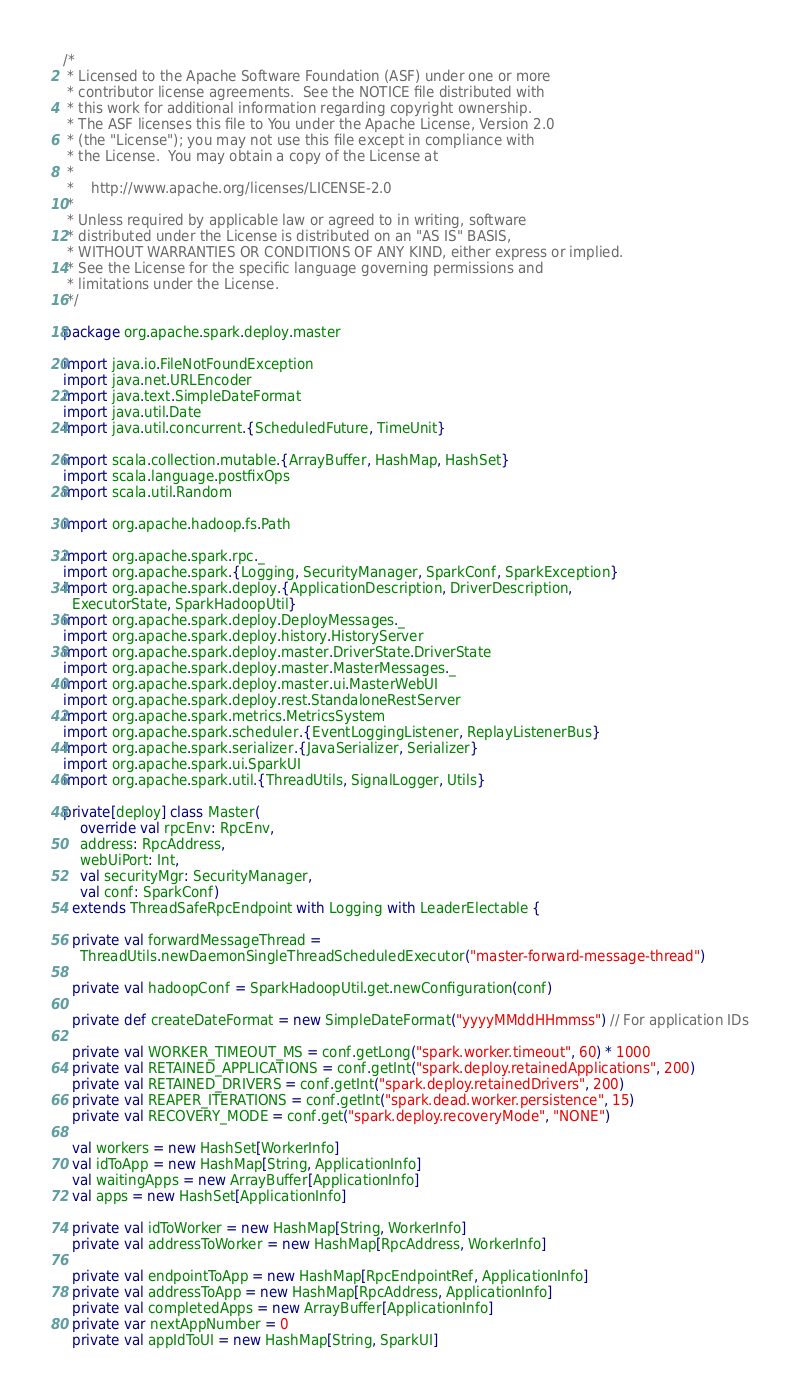Convert code to text. <code><loc_0><loc_0><loc_500><loc_500><_Scala_>/*
 * Licensed to the Apache Software Foundation (ASF) under one or more
 * contributor license agreements.  See the NOTICE file distributed with
 * this work for additional information regarding copyright ownership.
 * The ASF licenses this file to You under the Apache License, Version 2.0
 * (the "License"); you may not use this file except in compliance with
 * the License.  You may obtain a copy of the License at
 *
 *    http://www.apache.org/licenses/LICENSE-2.0
 *
 * Unless required by applicable law or agreed to in writing, software
 * distributed under the License is distributed on an "AS IS" BASIS,
 * WITHOUT WARRANTIES OR CONDITIONS OF ANY KIND, either express or implied.
 * See the License for the specific language governing permissions and
 * limitations under the License.
 */

package org.apache.spark.deploy.master

import java.io.FileNotFoundException
import java.net.URLEncoder
import java.text.SimpleDateFormat
import java.util.Date
import java.util.concurrent.{ScheduledFuture, TimeUnit}

import scala.collection.mutable.{ArrayBuffer, HashMap, HashSet}
import scala.language.postfixOps
import scala.util.Random

import org.apache.hadoop.fs.Path

import org.apache.spark.rpc._
import org.apache.spark.{Logging, SecurityManager, SparkConf, SparkException}
import org.apache.spark.deploy.{ApplicationDescription, DriverDescription,
  ExecutorState, SparkHadoopUtil}
import org.apache.spark.deploy.DeployMessages._
import org.apache.spark.deploy.history.HistoryServer
import org.apache.spark.deploy.master.DriverState.DriverState
import org.apache.spark.deploy.master.MasterMessages._
import org.apache.spark.deploy.master.ui.MasterWebUI
import org.apache.spark.deploy.rest.StandaloneRestServer
import org.apache.spark.metrics.MetricsSystem
import org.apache.spark.scheduler.{EventLoggingListener, ReplayListenerBus}
import org.apache.spark.serializer.{JavaSerializer, Serializer}
import org.apache.spark.ui.SparkUI
import org.apache.spark.util.{ThreadUtils, SignalLogger, Utils}

private[deploy] class Master(
    override val rpcEnv: RpcEnv,
    address: RpcAddress,
    webUiPort: Int,
    val securityMgr: SecurityManager,
    val conf: SparkConf)
  extends ThreadSafeRpcEndpoint with Logging with LeaderElectable {

  private val forwardMessageThread =
    ThreadUtils.newDaemonSingleThreadScheduledExecutor("master-forward-message-thread")

  private val hadoopConf = SparkHadoopUtil.get.newConfiguration(conf)

  private def createDateFormat = new SimpleDateFormat("yyyyMMddHHmmss") // For application IDs

  private val WORKER_TIMEOUT_MS = conf.getLong("spark.worker.timeout", 60) * 1000
  private val RETAINED_APPLICATIONS = conf.getInt("spark.deploy.retainedApplications", 200)
  private val RETAINED_DRIVERS = conf.getInt("spark.deploy.retainedDrivers", 200)
  private val REAPER_ITERATIONS = conf.getInt("spark.dead.worker.persistence", 15)
  private val RECOVERY_MODE = conf.get("spark.deploy.recoveryMode", "NONE")

  val workers = new HashSet[WorkerInfo]
  val idToApp = new HashMap[String, ApplicationInfo]
  val waitingApps = new ArrayBuffer[ApplicationInfo]
  val apps = new HashSet[ApplicationInfo]

  private val idToWorker = new HashMap[String, WorkerInfo]
  private val addressToWorker = new HashMap[RpcAddress, WorkerInfo]

  private val endpointToApp = new HashMap[RpcEndpointRef, ApplicationInfo]
  private val addressToApp = new HashMap[RpcAddress, ApplicationInfo]
  private val completedApps = new ArrayBuffer[ApplicationInfo]
  private var nextAppNumber = 0
  private val appIdToUI = new HashMap[String, SparkUI]
</code> 